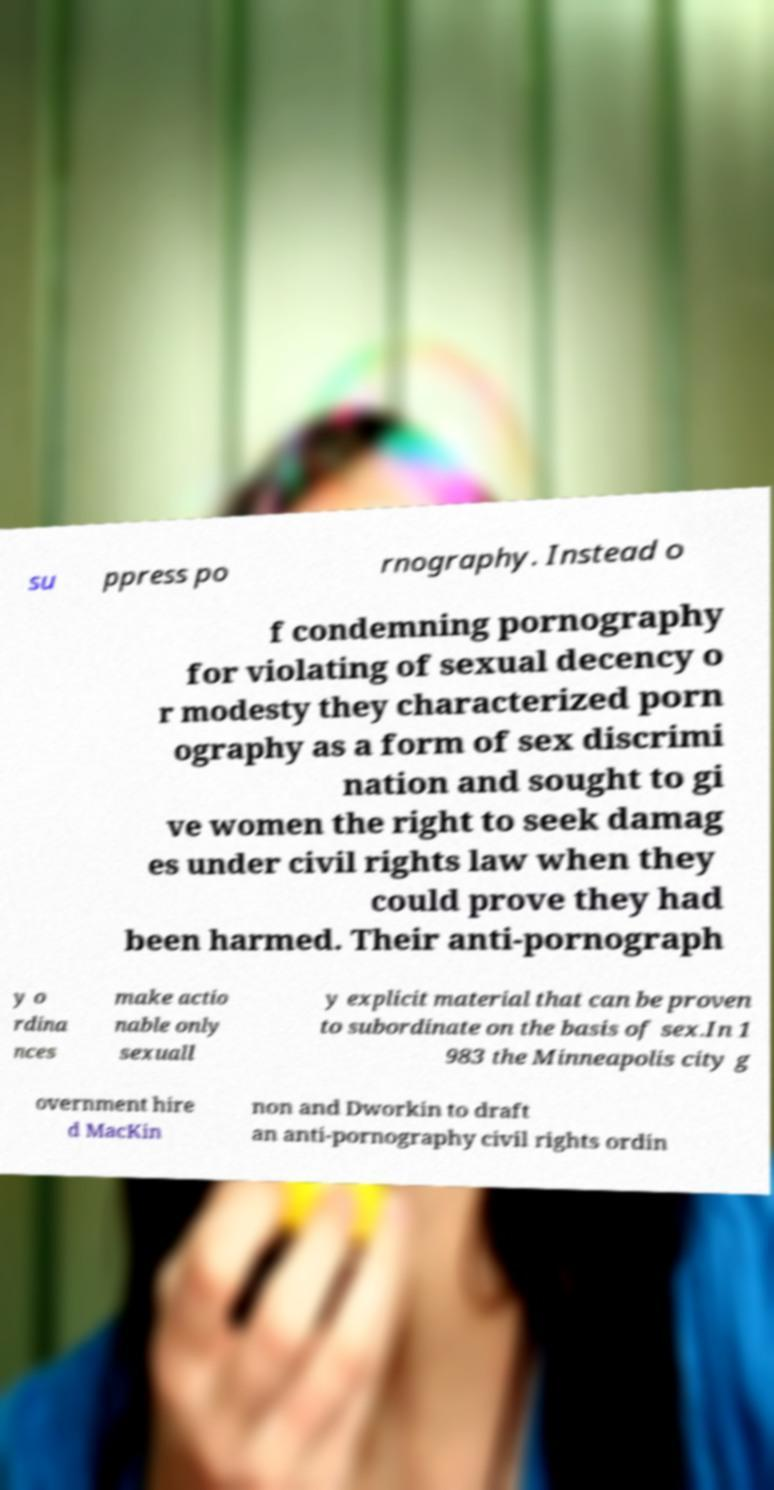Can you accurately transcribe the text from the provided image for me? su ppress po rnography. Instead o f condemning pornography for violating of sexual decency o r modesty they characterized porn ography as a form of sex discrimi nation and sought to gi ve women the right to seek damag es under civil rights law when they could prove they had been harmed. Their anti-pornograph y o rdina nces make actio nable only sexuall y explicit material that can be proven to subordinate on the basis of sex.In 1 983 the Minneapolis city g overnment hire d MacKin non and Dworkin to draft an anti-pornography civil rights ordin 